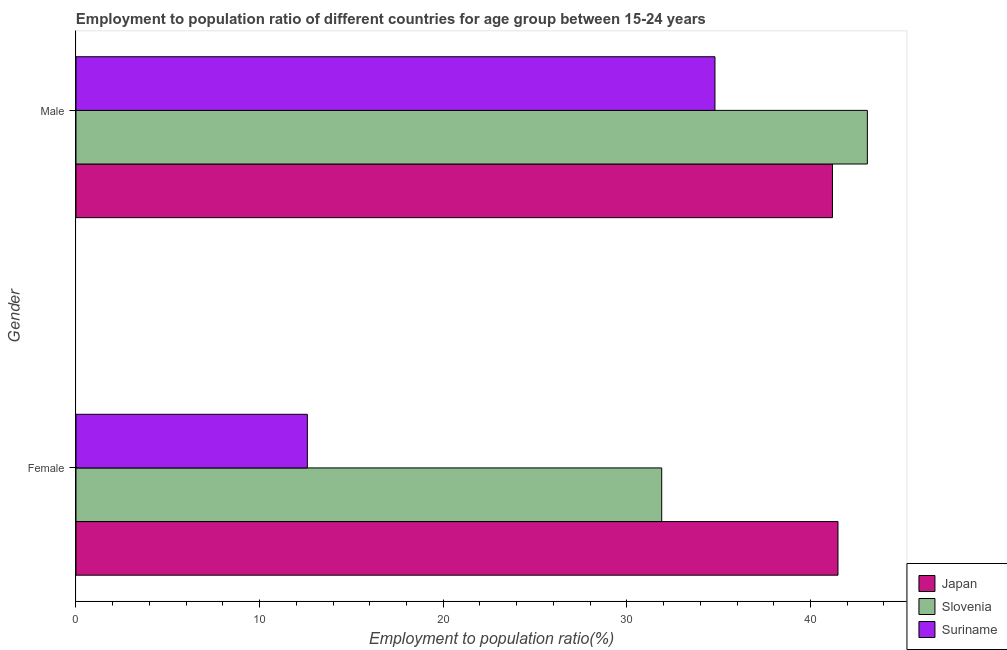How many different coloured bars are there?
Offer a terse response. 3. Are the number of bars per tick equal to the number of legend labels?
Ensure brevity in your answer.  Yes. Are the number of bars on each tick of the Y-axis equal?
Offer a very short reply. Yes. How many bars are there on the 2nd tick from the top?
Provide a short and direct response. 3. How many bars are there on the 1st tick from the bottom?
Your response must be concise. 3. What is the employment to population ratio(male) in Slovenia?
Your answer should be compact. 43.1. Across all countries, what is the maximum employment to population ratio(female)?
Give a very brief answer. 41.5. Across all countries, what is the minimum employment to population ratio(male)?
Offer a very short reply. 34.8. In which country was the employment to population ratio(male) maximum?
Give a very brief answer. Slovenia. In which country was the employment to population ratio(male) minimum?
Provide a succinct answer. Suriname. What is the difference between the employment to population ratio(male) in Japan and that in Suriname?
Ensure brevity in your answer.  6.4. What is the difference between the employment to population ratio(female) in Suriname and the employment to population ratio(male) in Japan?
Ensure brevity in your answer.  -28.6. What is the average employment to population ratio(female) per country?
Your response must be concise. 28.67. What is the difference between the employment to population ratio(female) and employment to population ratio(male) in Japan?
Offer a very short reply. 0.3. What is the ratio of the employment to population ratio(male) in Slovenia to that in Japan?
Provide a succinct answer. 1.05. Is the employment to population ratio(female) in Suriname less than that in Slovenia?
Your response must be concise. Yes. In how many countries, is the employment to population ratio(female) greater than the average employment to population ratio(female) taken over all countries?
Give a very brief answer. 2. What does the 2nd bar from the bottom in Female represents?
Provide a succinct answer. Slovenia. How many bars are there?
Your answer should be compact. 6. What is the difference between two consecutive major ticks on the X-axis?
Give a very brief answer. 10. Are the values on the major ticks of X-axis written in scientific E-notation?
Make the answer very short. No. Does the graph contain any zero values?
Give a very brief answer. No. Does the graph contain grids?
Your answer should be very brief. No. How are the legend labels stacked?
Your answer should be very brief. Vertical. What is the title of the graph?
Make the answer very short. Employment to population ratio of different countries for age group between 15-24 years. What is the label or title of the X-axis?
Ensure brevity in your answer.  Employment to population ratio(%). What is the label or title of the Y-axis?
Your response must be concise. Gender. What is the Employment to population ratio(%) of Japan in Female?
Your answer should be compact. 41.5. What is the Employment to population ratio(%) in Slovenia in Female?
Offer a terse response. 31.9. What is the Employment to population ratio(%) in Suriname in Female?
Offer a terse response. 12.6. What is the Employment to population ratio(%) in Japan in Male?
Offer a terse response. 41.2. What is the Employment to population ratio(%) in Slovenia in Male?
Your answer should be compact. 43.1. What is the Employment to population ratio(%) in Suriname in Male?
Offer a terse response. 34.8. Across all Gender, what is the maximum Employment to population ratio(%) in Japan?
Offer a terse response. 41.5. Across all Gender, what is the maximum Employment to population ratio(%) of Slovenia?
Your response must be concise. 43.1. Across all Gender, what is the maximum Employment to population ratio(%) of Suriname?
Offer a terse response. 34.8. Across all Gender, what is the minimum Employment to population ratio(%) of Japan?
Give a very brief answer. 41.2. Across all Gender, what is the minimum Employment to population ratio(%) of Slovenia?
Provide a succinct answer. 31.9. Across all Gender, what is the minimum Employment to population ratio(%) of Suriname?
Your response must be concise. 12.6. What is the total Employment to population ratio(%) of Japan in the graph?
Your response must be concise. 82.7. What is the total Employment to population ratio(%) in Suriname in the graph?
Make the answer very short. 47.4. What is the difference between the Employment to population ratio(%) in Japan in Female and that in Male?
Offer a terse response. 0.3. What is the difference between the Employment to population ratio(%) in Slovenia in Female and that in Male?
Offer a very short reply. -11.2. What is the difference between the Employment to population ratio(%) of Suriname in Female and that in Male?
Make the answer very short. -22.2. What is the difference between the Employment to population ratio(%) of Japan in Female and the Employment to population ratio(%) of Slovenia in Male?
Ensure brevity in your answer.  -1.6. What is the average Employment to population ratio(%) of Japan per Gender?
Your answer should be very brief. 41.35. What is the average Employment to population ratio(%) in Slovenia per Gender?
Give a very brief answer. 37.5. What is the average Employment to population ratio(%) of Suriname per Gender?
Make the answer very short. 23.7. What is the difference between the Employment to population ratio(%) of Japan and Employment to population ratio(%) of Slovenia in Female?
Offer a very short reply. 9.6. What is the difference between the Employment to population ratio(%) of Japan and Employment to population ratio(%) of Suriname in Female?
Ensure brevity in your answer.  28.9. What is the difference between the Employment to population ratio(%) in Slovenia and Employment to population ratio(%) in Suriname in Female?
Provide a succinct answer. 19.3. What is the difference between the Employment to population ratio(%) in Japan and Employment to population ratio(%) in Suriname in Male?
Your response must be concise. 6.4. What is the ratio of the Employment to population ratio(%) in Japan in Female to that in Male?
Make the answer very short. 1.01. What is the ratio of the Employment to population ratio(%) of Slovenia in Female to that in Male?
Give a very brief answer. 0.74. What is the ratio of the Employment to population ratio(%) in Suriname in Female to that in Male?
Offer a terse response. 0.36. What is the difference between the highest and the lowest Employment to population ratio(%) of Japan?
Offer a terse response. 0.3. What is the difference between the highest and the lowest Employment to population ratio(%) of Slovenia?
Give a very brief answer. 11.2. 